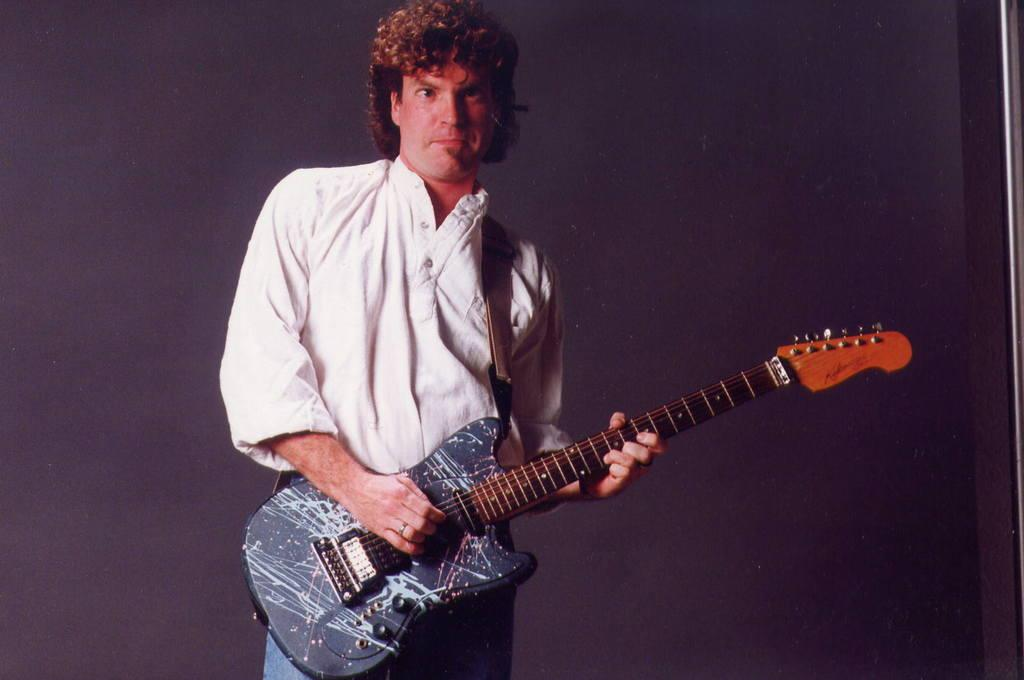What is the main subject of the picture? The main subject of the picture is a man. What is the man wearing in the picture? The man is wearing a white shirt in the picture. What is the man holding in the picture? The man is holding a guitar in the picture. What is the man doing with the guitar in the picture? The man is playing the guitar in the picture. What position is the man in while playing the guitar? The man is standing while playing the guitar in the picture. Can you see the man's toes in the picture? There is no information about the man's toes in the provided facts, so it cannot be determined if they are visible in the image. 